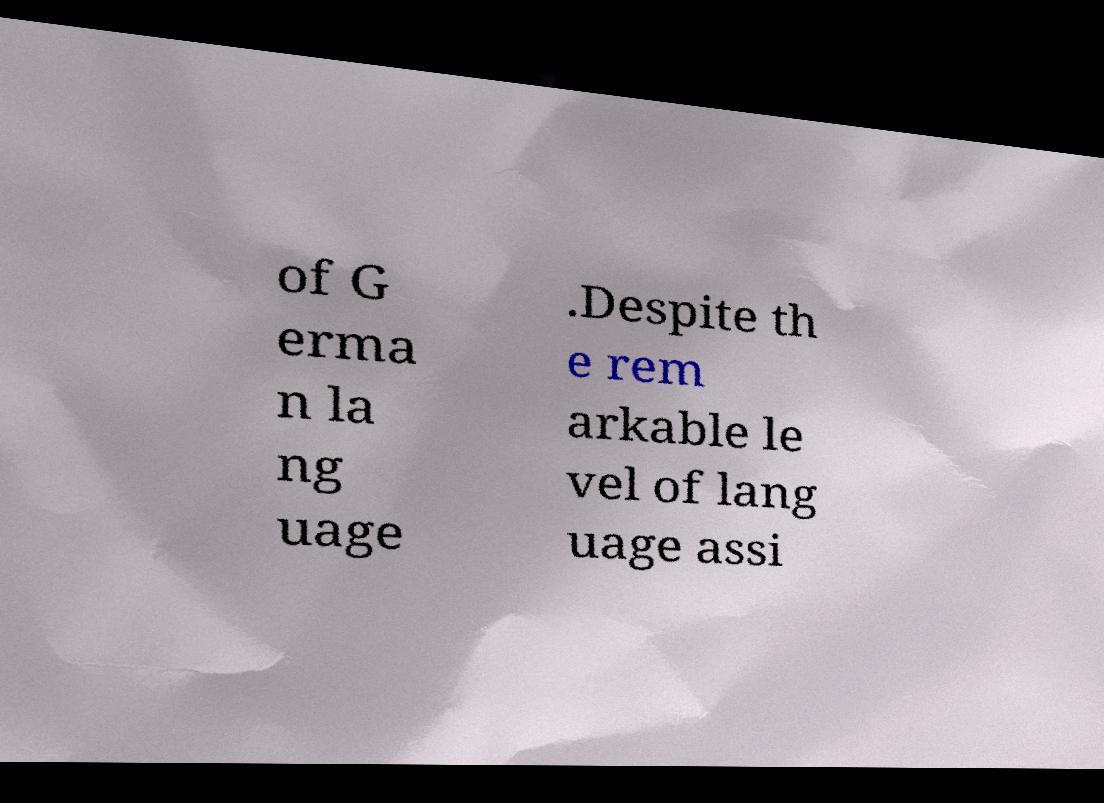Can you accurately transcribe the text from the provided image for me? of G erma n la ng uage .Despite th e rem arkable le vel of lang uage assi 